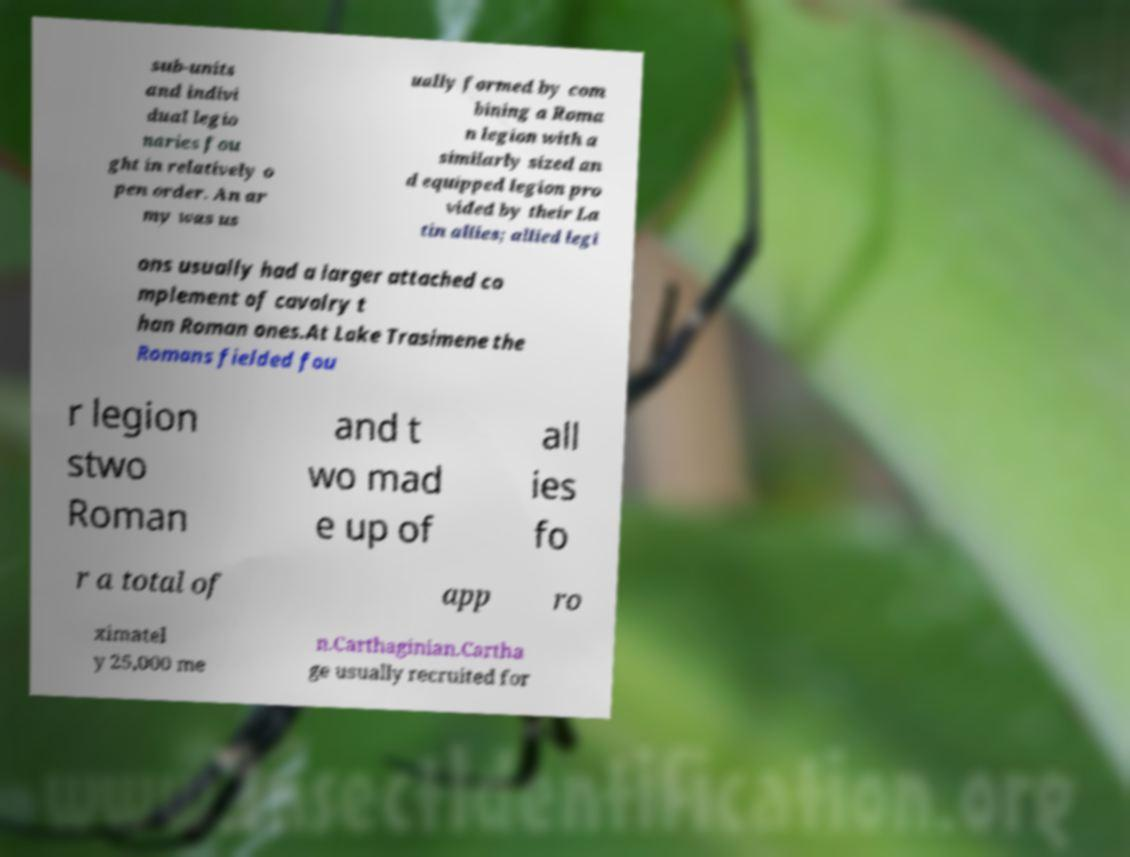What messages or text are displayed in this image? I need them in a readable, typed format. sub-units and indivi dual legio naries fou ght in relatively o pen order. An ar my was us ually formed by com bining a Roma n legion with a similarly sized an d equipped legion pro vided by their La tin allies; allied legi ons usually had a larger attached co mplement of cavalry t han Roman ones.At Lake Trasimene the Romans fielded fou r legion stwo Roman and t wo mad e up of all ies fo r a total of app ro ximatel y 25,000 me n.Carthaginian.Cartha ge usually recruited for 